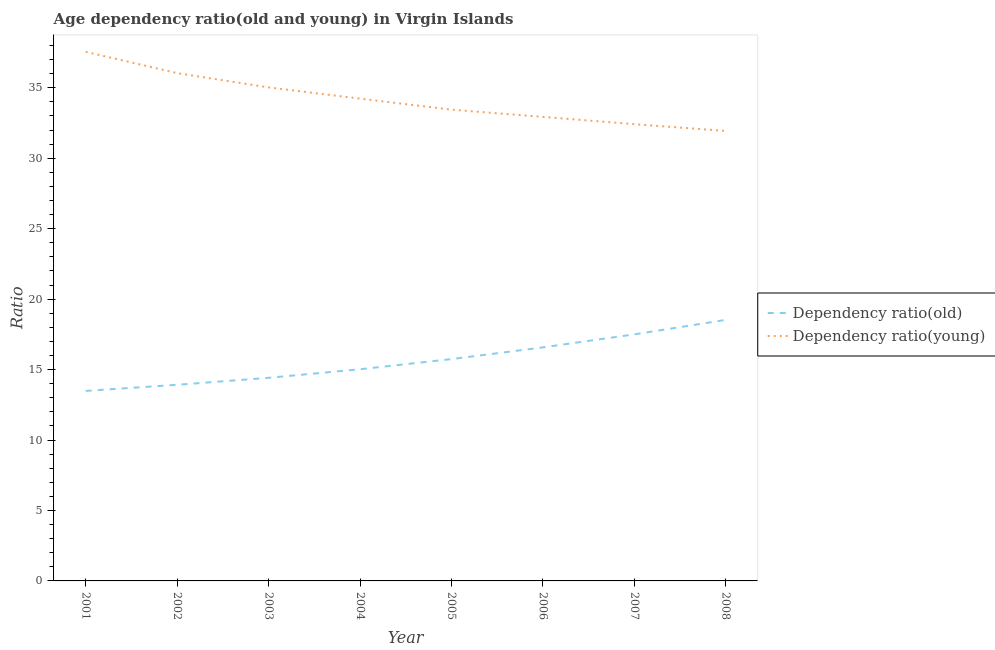Does the line corresponding to age dependency ratio(old) intersect with the line corresponding to age dependency ratio(young)?
Keep it short and to the point. No. What is the age dependency ratio(young) in 2008?
Make the answer very short. 31.93. Across all years, what is the maximum age dependency ratio(old)?
Your answer should be compact. 18.52. Across all years, what is the minimum age dependency ratio(young)?
Provide a short and direct response. 31.93. In which year was the age dependency ratio(old) maximum?
Your response must be concise. 2008. What is the total age dependency ratio(old) in the graph?
Your answer should be compact. 125.18. What is the difference between the age dependency ratio(young) in 2003 and that in 2004?
Give a very brief answer. 0.8. What is the difference between the age dependency ratio(young) in 2004 and the age dependency ratio(old) in 2007?
Keep it short and to the point. 16.73. What is the average age dependency ratio(old) per year?
Provide a succinct answer. 15.65. In the year 2002, what is the difference between the age dependency ratio(old) and age dependency ratio(young)?
Your response must be concise. -22.12. In how many years, is the age dependency ratio(old) greater than 6?
Offer a very short reply. 8. What is the ratio of the age dependency ratio(old) in 2002 to that in 2008?
Offer a terse response. 0.75. Is the difference between the age dependency ratio(young) in 2005 and 2008 greater than the difference between the age dependency ratio(old) in 2005 and 2008?
Make the answer very short. Yes. What is the difference between the highest and the second highest age dependency ratio(old)?
Keep it short and to the point. 1.03. What is the difference between the highest and the lowest age dependency ratio(young)?
Ensure brevity in your answer.  5.61. Is the sum of the age dependency ratio(old) in 2004 and 2005 greater than the maximum age dependency ratio(young) across all years?
Provide a succinct answer. No. Does the age dependency ratio(young) monotonically increase over the years?
Your answer should be compact. No. Is the age dependency ratio(old) strictly less than the age dependency ratio(young) over the years?
Offer a terse response. Yes. How many lines are there?
Ensure brevity in your answer.  2. What is the difference between two consecutive major ticks on the Y-axis?
Your answer should be very brief. 5. Does the graph contain any zero values?
Ensure brevity in your answer.  No. Does the graph contain grids?
Offer a very short reply. No. How are the legend labels stacked?
Give a very brief answer. Vertical. What is the title of the graph?
Keep it short and to the point. Age dependency ratio(old and young) in Virgin Islands. What is the label or title of the X-axis?
Your answer should be compact. Year. What is the label or title of the Y-axis?
Offer a very short reply. Ratio. What is the Ratio in Dependency ratio(old) in 2001?
Ensure brevity in your answer.  13.48. What is the Ratio of Dependency ratio(young) in 2001?
Your response must be concise. 37.55. What is the Ratio of Dependency ratio(old) in 2002?
Your response must be concise. 13.92. What is the Ratio of Dependency ratio(young) in 2002?
Offer a terse response. 36.04. What is the Ratio in Dependency ratio(old) in 2003?
Provide a short and direct response. 14.41. What is the Ratio in Dependency ratio(young) in 2003?
Provide a short and direct response. 35.02. What is the Ratio in Dependency ratio(old) in 2004?
Your response must be concise. 15.02. What is the Ratio in Dependency ratio(young) in 2004?
Offer a terse response. 34.23. What is the Ratio of Dependency ratio(old) in 2005?
Ensure brevity in your answer.  15.74. What is the Ratio of Dependency ratio(young) in 2005?
Give a very brief answer. 33.45. What is the Ratio in Dependency ratio(old) in 2006?
Make the answer very short. 16.57. What is the Ratio of Dependency ratio(young) in 2006?
Provide a succinct answer. 32.93. What is the Ratio of Dependency ratio(old) in 2007?
Give a very brief answer. 17.5. What is the Ratio in Dependency ratio(young) in 2007?
Your answer should be compact. 32.42. What is the Ratio in Dependency ratio(old) in 2008?
Your answer should be compact. 18.52. What is the Ratio of Dependency ratio(young) in 2008?
Your response must be concise. 31.93. Across all years, what is the maximum Ratio of Dependency ratio(old)?
Your response must be concise. 18.52. Across all years, what is the maximum Ratio of Dependency ratio(young)?
Give a very brief answer. 37.55. Across all years, what is the minimum Ratio in Dependency ratio(old)?
Your response must be concise. 13.48. Across all years, what is the minimum Ratio in Dependency ratio(young)?
Offer a terse response. 31.93. What is the total Ratio in Dependency ratio(old) in the graph?
Give a very brief answer. 125.18. What is the total Ratio of Dependency ratio(young) in the graph?
Your answer should be compact. 273.56. What is the difference between the Ratio of Dependency ratio(old) in 2001 and that in 2002?
Offer a very short reply. -0.43. What is the difference between the Ratio in Dependency ratio(young) in 2001 and that in 2002?
Your response must be concise. 1.51. What is the difference between the Ratio of Dependency ratio(old) in 2001 and that in 2003?
Ensure brevity in your answer.  -0.93. What is the difference between the Ratio of Dependency ratio(young) in 2001 and that in 2003?
Your response must be concise. 2.52. What is the difference between the Ratio of Dependency ratio(old) in 2001 and that in 2004?
Give a very brief answer. -1.54. What is the difference between the Ratio in Dependency ratio(young) in 2001 and that in 2004?
Your response must be concise. 3.32. What is the difference between the Ratio of Dependency ratio(old) in 2001 and that in 2005?
Your answer should be compact. -2.26. What is the difference between the Ratio of Dependency ratio(young) in 2001 and that in 2005?
Provide a succinct answer. 4.1. What is the difference between the Ratio in Dependency ratio(old) in 2001 and that in 2006?
Provide a succinct answer. -3.09. What is the difference between the Ratio of Dependency ratio(young) in 2001 and that in 2006?
Your answer should be very brief. 4.62. What is the difference between the Ratio of Dependency ratio(old) in 2001 and that in 2007?
Your response must be concise. -4.01. What is the difference between the Ratio of Dependency ratio(young) in 2001 and that in 2007?
Your answer should be compact. 5.13. What is the difference between the Ratio of Dependency ratio(old) in 2001 and that in 2008?
Give a very brief answer. -5.04. What is the difference between the Ratio in Dependency ratio(young) in 2001 and that in 2008?
Offer a terse response. 5.61. What is the difference between the Ratio of Dependency ratio(old) in 2002 and that in 2003?
Your answer should be compact. -0.49. What is the difference between the Ratio in Dependency ratio(young) in 2002 and that in 2003?
Offer a very short reply. 1.01. What is the difference between the Ratio in Dependency ratio(old) in 2002 and that in 2004?
Offer a terse response. -1.1. What is the difference between the Ratio in Dependency ratio(young) in 2002 and that in 2004?
Make the answer very short. 1.81. What is the difference between the Ratio in Dependency ratio(old) in 2002 and that in 2005?
Offer a very short reply. -1.82. What is the difference between the Ratio of Dependency ratio(young) in 2002 and that in 2005?
Your answer should be very brief. 2.59. What is the difference between the Ratio in Dependency ratio(old) in 2002 and that in 2006?
Ensure brevity in your answer.  -2.65. What is the difference between the Ratio in Dependency ratio(young) in 2002 and that in 2006?
Your response must be concise. 3.11. What is the difference between the Ratio of Dependency ratio(old) in 2002 and that in 2007?
Make the answer very short. -3.58. What is the difference between the Ratio in Dependency ratio(young) in 2002 and that in 2007?
Ensure brevity in your answer.  3.62. What is the difference between the Ratio in Dependency ratio(old) in 2002 and that in 2008?
Ensure brevity in your answer.  -4.61. What is the difference between the Ratio of Dependency ratio(young) in 2002 and that in 2008?
Make the answer very short. 4.1. What is the difference between the Ratio of Dependency ratio(old) in 2003 and that in 2004?
Make the answer very short. -0.61. What is the difference between the Ratio of Dependency ratio(young) in 2003 and that in 2004?
Your answer should be very brief. 0.8. What is the difference between the Ratio of Dependency ratio(old) in 2003 and that in 2005?
Ensure brevity in your answer.  -1.33. What is the difference between the Ratio of Dependency ratio(young) in 2003 and that in 2005?
Ensure brevity in your answer.  1.58. What is the difference between the Ratio of Dependency ratio(old) in 2003 and that in 2006?
Provide a short and direct response. -2.16. What is the difference between the Ratio in Dependency ratio(young) in 2003 and that in 2006?
Your response must be concise. 2.09. What is the difference between the Ratio in Dependency ratio(old) in 2003 and that in 2007?
Offer a very short reply. -3.08. What is the difference between the Ratio of Dependency ratio(young) in 2003 and that in 2007?
Offer a very short reply. 2.61. What is the difference between the Ratio of Dependency ratio(old) in 2003 and that in 2008?
Your answer should be compact. -4.11. What is the difference between the Ratio in Dependency ratio(young) in 2003 and that in 2008?
Make the answer very short. 3.09. What is the difference between the Ratio of Dependency ratio(old) in 2004 and that in 2005?
Your answer should be compact. -0.72. What is the difference between the Ratio in Dependency ratio(young) in 2004 and that in 2005?
Offer a terse response. 0.78. What is the difference between the Ratio in Dependency ratio(old) in 2004 and that in 2006?
Offer a terse response. -1.55. What is the difference between the Ratio in Dependency ratio(young) in 2004 and that in 2006?
Provide a short and direct response. 1.3. What is the difference between the Ratio of Dependency ratio(old) in 2004 and that in 2007?
Offer a very short reply. -2.48. What is the difference between the Ratio of Dependency ratio(young) in 2004 and that in 2007?
Give a very brief answer. 1.81. What is the difference between the Ratio in Dependency ratio(old) in 2004 and that in 2008?
Offer a very short reply. -3.5. What is the difference between the Ratio in Dependency ratio(young) in 2004 and that in 2008?
Provide a succinct answer. 2.29. What is the difference between the Ratio in Dependency ratio(old) in 2005 and that in 2006?
Ensure brevity in your answer.  -0.83. What is the difference between the Ratio in Dependency ratio(young) in 2005 and that in 2006?
Your answer should be very brief. 0.51. What is the difference between the Ratio in Dependency ratio(old) in 2005 and that in 2007?
Give a very brief answer. -1.75. What is the difference between the Ratio in Dependency ratio(young) in 2005 and that in 2007?
Your response must be concise. 1.03. What is the difference between the Ratio of Dependency ratio(old) in 2005 and that in 2008?
Provide a short and direct response. -2.78. What is the difference between the Ratio in Dependency ratio(young) in 2005 and that in 2008?
Ensure brevity in your answer.  1.51. What is the difference between the Ratio of Dependency ratio(old) in 2006 and that in 2007?
Offer a very short reply. -0.92. What is the difference between the Ratio of Dependency ratio(young) in 2006 and that in 2007?
Your answer should be very brief. 0.52. What is the difference between the Ratio in Dependency ratio(old) in 2006 and that in 2008?
Offer a terse response. -1.95. What is the difference between the Ratio in Dependency ratio(old) in 2007 and that in 2008?
Give a very brief answer. -1.03. What is the difference between the Ratio in Dependency ratio(young) in 2007 and that in 2008?
Provide a short and direct response. 0.48. What is the difference between the Ratio of Dependency ratio(old) in 2001 and the Ratio of Dependency ratio(young) in 2002?
Make the answer very short. -22.55. What is the difference between the Ratio in Dependency ratio(old) in 2001 and the Ratio in Dependency ratio(young) in 2003?
Provide a short and direct response. -21.54. What is the difference between the Ratio of Dependency ratio(old) in 2001 and the Ratio of Dependency ratio(young) in 2004?
Offer a terse response. -20.74. What is the difference between the Ratio in Dependency ratio(old) in 2001 and the Ratio in Dependency ratio(young) in 2005?
Provide a short and direct response. -19.96. What is the difference between the Ratio in Dependency ratio(old) in 2001 and the Ratio in Dependency ratio(young) in 2006?
Your answer should be very brief. -19.45. What is the difference between the Ratio of Dependency ratio(old) in 2001 and the Ratio of Dependency ratio(young) in 2007?
Offer a terse response. -18.93. What is the difference between the Ratio in Dependency ratio(old) in 2001 and the Ratio in Dependency ratio(young) in 2008?
Provide a succinct answer. -18.45. What is the difference between the Ratio of Dependency ratio(old) in 2002 and the Ratio of Dependency ratio(young) in 2003?
Offer a terse response. -21.1. What is the difference between the Ratio in Dependency ratio(old) in 2002 and the Ratio in Dependency ratio(young) in 2004?
Provide a short and direct response. -20.31. What is the difference between the Ratio in Dependency ratio(old) in 2002 and the Ratio in Dependency ratio(young) in 2005?
Your response must be concise. -19.53. What is the difference between the Ratio of Dependency ratio(old) in 2002 and the Ratio of Dependency ratio(young) in 2006?
Your answer should be very brief. -19.01. What is the difference between the Ratio of Dependency ratio(old) in 2002 and the Ratio of Dependency ratio(young) in 2007?
Make the answer very short. -18.5. What is the difference between the Ratio of Dependency ratio(old) in 2002 and the Ratio of Dependency ratio(young) in 2008?
Provide a succinct answer. -18.02. What is the difference between the Ratio of Dependency ratio(old) in 2003 and the Ratio of Dependency ratio(young) in 2004?
Ensure brevity in your answer.  -19.81. What is the difference between the Ratio of Dependency ratio(old) in 2003 and the Ratio of Dependency ratio(young) in 2005?
Ensure brevity in your answer.  -19.03. What is the difference between the Ratio of Dependency ratio(old) in 2003 and the Ratio of Dependency ratio(young) in 2006?
Give a very brief answer. -18.52. What is the difference between the Ratio in Dependency ratio(old) in 2003 and the Ratio in Dependency ratio(young) in 2007?
Ensure brevity in your answer.  -18. What is the difference between the Ratio in Dependency ratio(old) in 2003 and the Ratio in Dependency ratio(young) in 2008?
Give a very brief answer. -17.52. What is the difference between the Ratio in Dependency ratio(old) in 2004 and the Ratio in Dependency ratio(young) in 2005?
Your answer should be very brief. -18.42. What is the difference between the Ratio in Dependency ratio(old) in 2004 and the Ratio in Dependency ratio(young) in 2006?
Your response must be concise. -17.91. What is the difference between the Ratio in Dependency ratio(old) in 2004 and the Ratio in Dependency ratio(young) in 2007?
Make the answer very short. -17.39. What is the difference between the Ratio in Dependency ratio(old) in 2004 and the Ratio in Dependency ratio(young) in 2008?
Give a very brief answer. -16.91. What is the difference between the Ratio in Dependency ratio(old) in 2005 and the Ratio in Dependency ratio(young) in 2006?
Your response must be concise. -17.19. What is the difference between the Ratio in Dependency ratio(old) in 2005 and the Ratio in Dependency ratio(young) in 2007?
Your answer should be very brief. -16.67. What is the difference between the Ratio in Dependency ratio(old) in 2005 and the Ratio in Dependency ratio(young) in 2008?
Your response must be concise. -16.19. What is the difference between the Ratio of Dependency ratio(old) in 2006 and the Ratio of Dependency ratio(young) in 2007?
Your answer should be very brief. -15.84. What is the difference between the Ratio in Dependency ratio(old) in 2006 and the Ratio in Dependency ratio(young) in 2008?
Your answer should be compact. -15.36. What is the difference between the Ratio in Dependency ratio(old) in 2007 and the Ratio in Dependency ratio(young) in 2008?
Provide a succinct answer. -14.44. What is the average Ratio in Dependency ratio(old) per year?
Provide a succinct answer. 15.65. What is the average Ratio of Dependency ratio(young) per year?
Your response must be concise. 34.2. In the year 2001, what is the difference between the Ratio in Dependency ratio(old) and Ratio in Dependency ratio(young)?
Provide a short and direct response. -24.06. In the year 2002, what is the difference between the Ratio of Dependency ratio(old) and Ratio of Dependency ratio(young)?
Your answer should be compact. -22.12. In the year 2003, what is the difference between the Ratio in Dependency ratio(old) and Ratio in Dependency ratio(young)?
Your answer should be compact. -20.61. In the year 2004, what is the difference between the Ratio of Dependency ratio(old) and Ratio of Dependency ratio(young)?
Make the answer very short. -19.21. In the year 2005, what is the difference between the Ratio in Dependency ratio(old) and Ratio in Dependency ratio(young)?
Provide a short and direct response. -17.7. In the year 2006, what is the difference between the Ratio in Dependency ratio(old) and Ratio in Dependency ratio(young)?
Your response must be concise. -16.36. In the year 2007, what is the difference between the Ratio of Dependency ratio(old) and Ratio of Dependency ratio(young)?
Your response must be concise. -14.92. In the year 2008, what is the difference between the Ratio in Dependency ratio(old) and Ratio in Dependency ratio(young)?
Your answer should be compact. -13.41. What is the ratio of the Ratio in Dependency ratio(old) in 2001 to that in 2002?
Offer a terse response. 0.97. What is the ratio of the Ratio in Dependency ratio(young) in 2001 to that in 2002?
Make the answer very short. 1.04. What is the ratio of the Ratio in Dependency ratio(old) in 2001 to that in 2003?
Provide a succinct answer. 0.94. What is the ratio of the Ratio of Dependency ratio(young) in 2001 to that in 2003?
Ensure brevity in your answer.  1.07. What is the ratio of the Ratio of Dependency ratio(old) in 2001 to that in 2004?
Provide a short and direct response. 0.9. What is the ratio of the Ratio in Dependency ratio(young) in 2001 to that in 2004?
Give a very brief answer. 1.1. What is the ratio of the Ratio of Dependency ratio(old) in 2001 to that in 2005?
Offer a terse response. 0.86. What is the ratio of the Ratio of Dependency ratio(young) in 2001 to that in 2005?
Give a very brief answer. 1.12. What is the ratio of the Ratio in Dependency ratio(old) in 2001 to that in 2006?
Provide a short and direct response. 0.81. What is the ratio of the Ratio of Dependency ratio(young) in 2001 to that in 2006?
Your answer should be compact. 1.14. What is the ratio of the Ratio in Dependency ratio(old) in 2001 to that in 2007?
Make the answer very short. 0.77. What is the ratio of the Ratio in Dependency ratio(young) in 2001 to that in 2007?
Offer a very short reply. 1.16. What is the ratio of the Ratio in Dependency ratio(old) in 2001 to that in 2008?
Provide a short and direct response. 0.73. What is the ratio of the Ratio of Dependency ratio(young) in 2001 to that in 2008?
Your response must be concise. 1.18. What is the ratio of the Ratio in Dependency ratio(old) in 2002 to that in 2003?
Offer a terse response. 0.97. What is the ratio of the Ratio in Dependency ratio(old) in 2002 to that in 2004?
Keep it short and to the point. 0.93. What is the ratio of the Ratio in Dependency ratio(young) in 2002 to that in 2004?
Your answer should be compact. 1.05. What is the ratio of the Ratio of Dependency ratio(old) in 2002 to that in 2005?
Keep it short and to the point. 0.88. What is the ratio of the Ratio of Dependency ratio(young) in 2002 to that in 2005?
Your answer should be very brief. 1.08. What is the ratio of the Ratio in Dependency ratio(old) in 2002 to that in 2006?
Ensure brevity in your answer.  0.84. What is the ratio of the Ratio in Dependency ratio(young) in 2002 to that in 2006?
Keep it short and to the point. 1.09. What is the ratio of the Ratio in Dependency ratio(old) in 2002 to that in 2007?
Provide a succinct answer. 0.8. What is the ratio of the Ratio in Dependency ratio(young) in 2002 to that in 2007?
Your answer should be compact. 1.11. What is the ratio of the Ratio in Dependency ratio(old) in 2002 to that in 2008?
Give a very brief answer. 0.75. What is the ratio of the Ratio of Dependency ratio(young) in 2002 to that in 2008?
Your answer should be very brief. 1.13. What is the ratio of the Ratio of Dependency ratio(old) in 2003 to that in 2004?
Offer a very short reply. 0.96. What is the ratio of the Ratio in Dependency ratio(young) in 2003 to that in 2004?
Your response must be concise. 1.02. What is the ratio of the Ratio of Dependency ratio(old) in 2003 to that in 2005?
Your answer should be very brief. 0.92. What is the ratio of the Ratio in Dependency ratio(young) in 2003 to that in 2005?
Offer a terse response. 1.05. What is the ratio of the Ratio of Dependency ratio(old) in 2003 to that in 2006?
Keep it short and to the point. 0.87. What is the ratio of the Ratio of Dependency ratio(young) in 2003 to that in 2006?
Offer a terse response. 1.06. What is the ratio of the Ratio of Dependency ratio(old) in 2003 to that in 2007?
Your answer should be compact. 0.82. What is the ratio of the Ratio of Dependency ratio(young) in 2003 to that in 2007?
Offer a terse response. 1.08. What is the ratio of the Ratio of Dependency ratio(old) in 2003 to that in 2008?
Give a very brief answer. 0.78. What is the ratio of the Ratio of Dependency ratio(young) in 2003 to that in 2008?
Your answer should be compact. 1.1. What is the ratio of the Ratio of Dependency ratio(old) in 2004 to that in 2005?
Make the answer very short. 0.95. What is the ratio of the Ratio in Dependency ratio(young) in 2004 to that in 2005?
Your answer should be very brief. 1.02. What is the ratio of the Ratio in Dependency ratio(old) in 2004 to that in 2006?
Offer a very short reply. 0.91. What is the ratio of the Ratio in Dependency ratio(young) in 2004 to that in 2006?
Your answer should be compact. 1.04. What is the ratio of the Ratio of Dependency ratio(old) in 2004 to that in 2007?
Your response must be concise. 0.86. What is the ratio of the Ratio of Dependency ratio(young) in 2004 to that in 2007?
Provide a short and direct response. 1.06. What is the ratio of the Ratio in Dependency ratio(old) in 2004 to that in 2008?
Keep it short and to the point. 0.81. What is the ratio of the Ratio of Dependency ratio(young) in 2004 to that in 2008?
Your response must be concise. 1.07. What is the ratio of the Ratio of Dependency ratio(old) in 2005 to that in 2006?
Keep it short and to the point. 0.95. What is the ratio of the Ratio in Dependency ratio(young) in 2005 to that in 2006?
Provide a short and direct response. 1.02. What is the ratio of the Ratio in Dependency ratio(old) in 2005 to that in 2007?
Provide a short and direct response. 0.9. What is the ratio of the Ratio in Dependency ratio(young) in 2005 to that in 2007?
Make the answer very short. 1.03. What is the ratio of the Ratio in Dependency ratio(old) in 2005 to that in 2008?
Your response must be concise. 0.85. What is the ratio of the Ratio in Dependency ratio(young) in 2005 to that in 2008?
Ensure brevity in your answer.  1.05. What is the ratio of the Ratio in Dependency ratio(old) in 2006 to that in 2007?
Your response must be concise. 0.95. What is the ratio of the Ratio of Dependency ratio(young) in 2006 to that in 2007?
Ensure brevity in your answer.  1.02. What is the ratio of the Ratio in Dependency ratio(old) in 2006 to that in 2008?
Give a very brief answer. 0.89. What is the ratio of the Ratio in Dependency ratio(young) in 2006 to that in 2008?
Give a very brief answer. 1.03. What is the ratio of the Ratio in Dependency ratio(old) in 2007 to that in 2008?
Make the answer very short. 0.94. What is the difference between the highest and the second highest Ratio in Dependency ratio(old)?
Keep it short and to the point. 1.03. What is the difference between the highest and the second highest Ratio in Dependency ratio(young)?
Offer a terse response. 1.51. What is the difference between the highest and the lowest Ratio in Dependency ratio(old)?
Your answer should be compact. 5.04. What is the difference between the highest and the lowest Ratio of Dependency ratio(young)?
Ensure brevity in your answer.  5.61. 